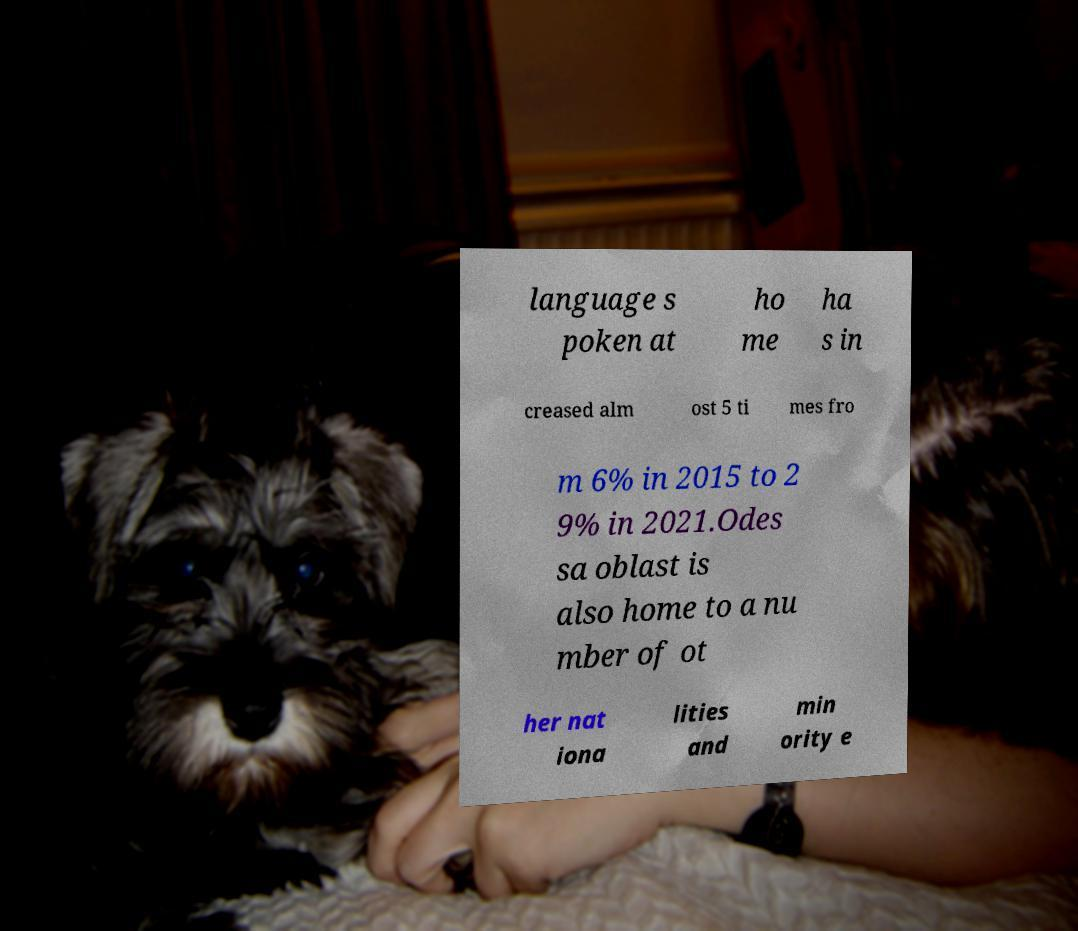I need the written content from this picture converted into text. Can you do that? language s poken at ho me ha s in creased alm ost 5 ti mes fro m 6% in 2015 to 2 9% in 2021.Odes sa oblast is also home to a nu mber of ot her nat iona lities and min ority e 